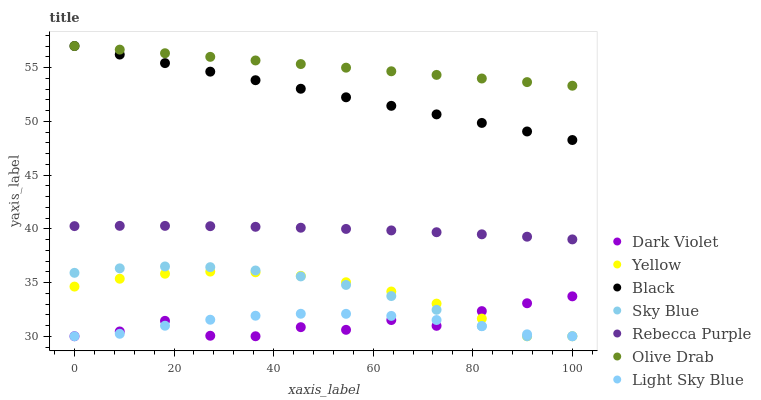Does Dark Violet have the minimum area under the curve?
Answer yes or no. Yes. Does Olive Drab have the maximum area under the curve?
Answer yes or no. Yes. Does Light Sky Blue have the minimum area under the curve?
Answer yes or no. No. Does Light Sky Blue have the maximum area under the curve?
Answer yes or no. No. Is Black the smoothest?
Answer yes or no. Yes. Is Dark Violet the roughest?
Answer yes or no. Yes. Is Light Sky Blue the smoothest?
Answer yes or no. No. Is Light Sky Blue the roughest?
Answer yes or no. No. Does Yellow have the lowest value?
Answer yes or no. Yes. Does Black have the lowest value?
Answer yes or no. No. Does Olive Drab have the highest value?
Answer yes or no. Yes. Does Light Sky Blue have the highest value?
Answer yes or no. No. Is Yellow less than Rebecca Purple?
Answer yes or no. Yes. Is Black greater than Rebecca Purple?
Answer yes or no. Yes. Does Yellow intersect Dark Violet?
Answer yes or no. Yes. Is Yellow less than Dark Violet?
Answer yes or no. No. Is Yellow greater than Dark Violet?
Answer yes or no. No. Does Yellow intersect Rebecca Purple?
Answer yes or no. No. 